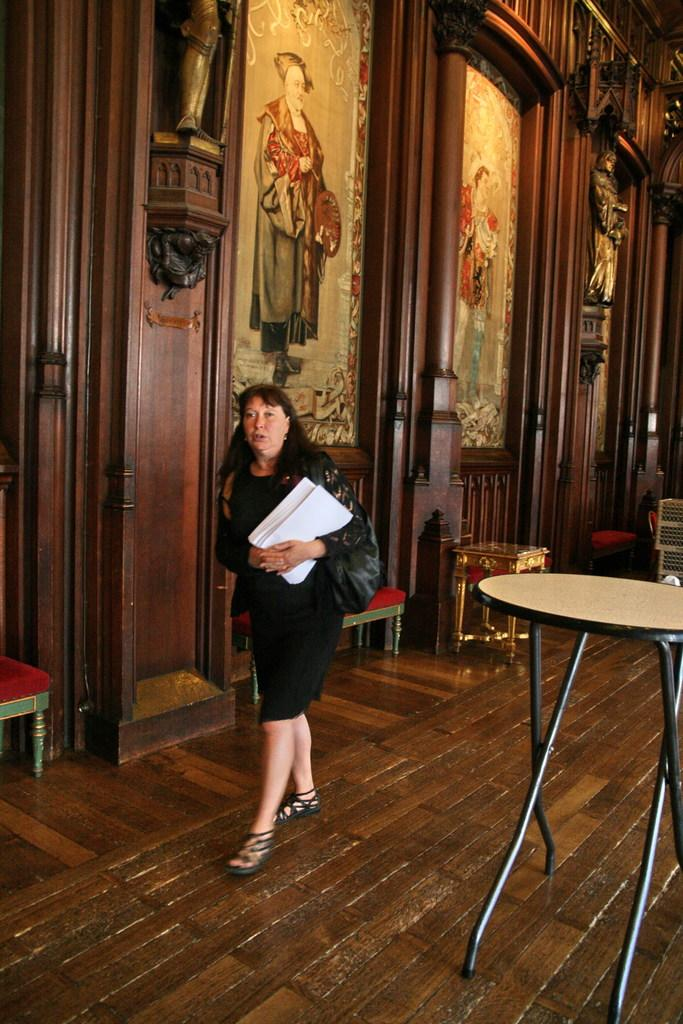Who is present in the image? There is a woman in the image. What is the woman holding? The woman is holding papers. What is the woman doing in the image? The woman is walking. What type of wall can be seen in the image? There is a wooden wall in the image. What is on the wooden wall? The wooden wall contains statues. How many tables are visible in the image? There are four tables in the image. What flavor of chickens can be seen on the street in the image? There are no chickens or streets present in the image. 